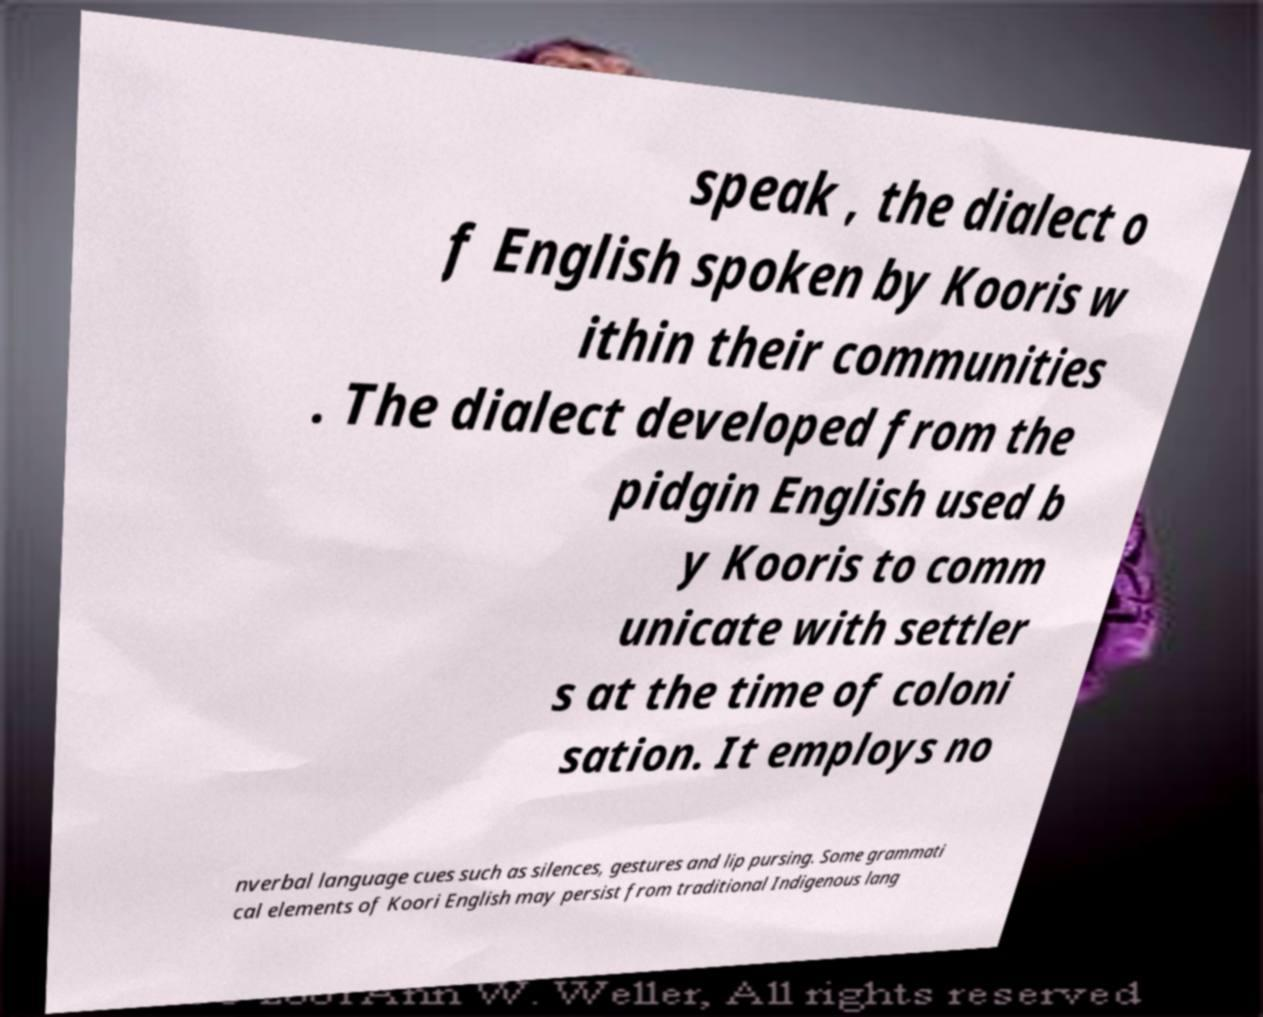Can you read and provide the text displayed in the image?This photo seems to have some interesting text. Can you extract and type it out for me? speak , the dialect o f English spoken by Kooris w ithin their communities . The dialect developed from the pidgin English used b y Kooris to comm unicate with settler s at the time of coloni sation. It employs no nverbal language cues such as silences, gestures and lip pursing. Some grammati cal elements of Koori English may persist from traditional Indigenous lang 